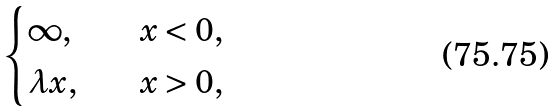Convert formula to latex. <formula><loc_0><loc_0><loc_500><loc_500>\begin{cases} \infty , \quad & x < 0 , \\ \lambda x , & x > 0 , \end{cases}</formula> 